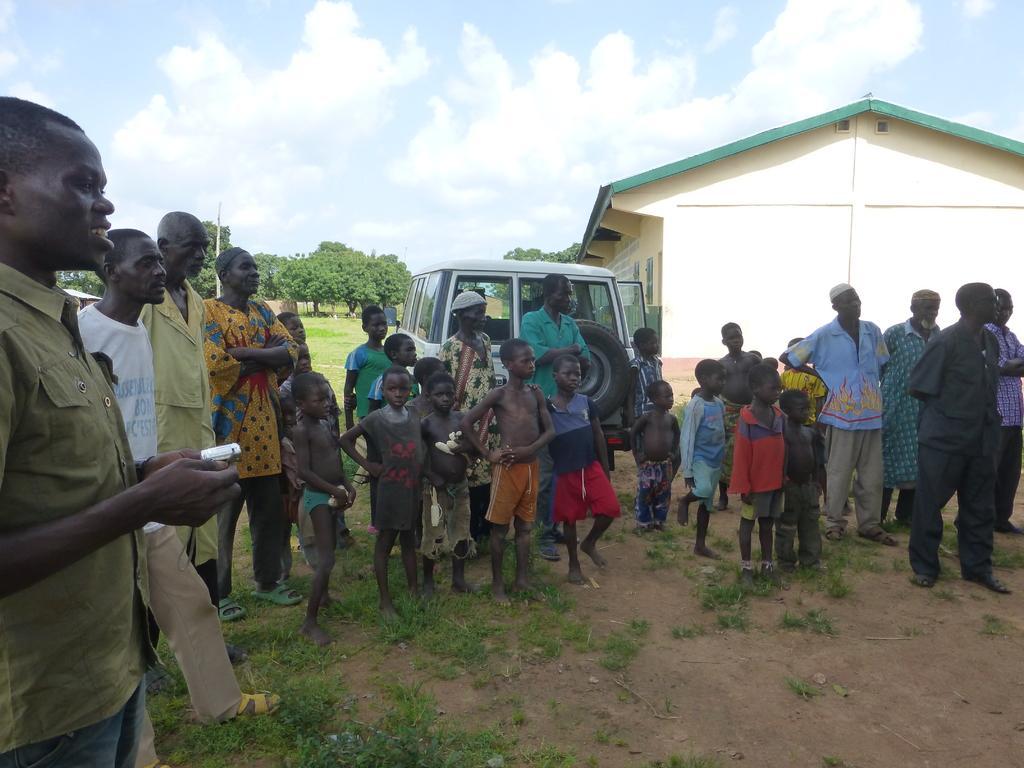Can you describe this image briefly? In this image we can see people standing on the ground. In the background there are sky with clouds, building, motor vehicle, trees and grass. 